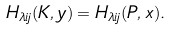Convert formula to latex. <formula><loc_0><loc_0><loc_500><loc_500>H _ { \lambda i j } ( K , y ) = H _ { \lambda i j } ( P , x ) .</formula> 